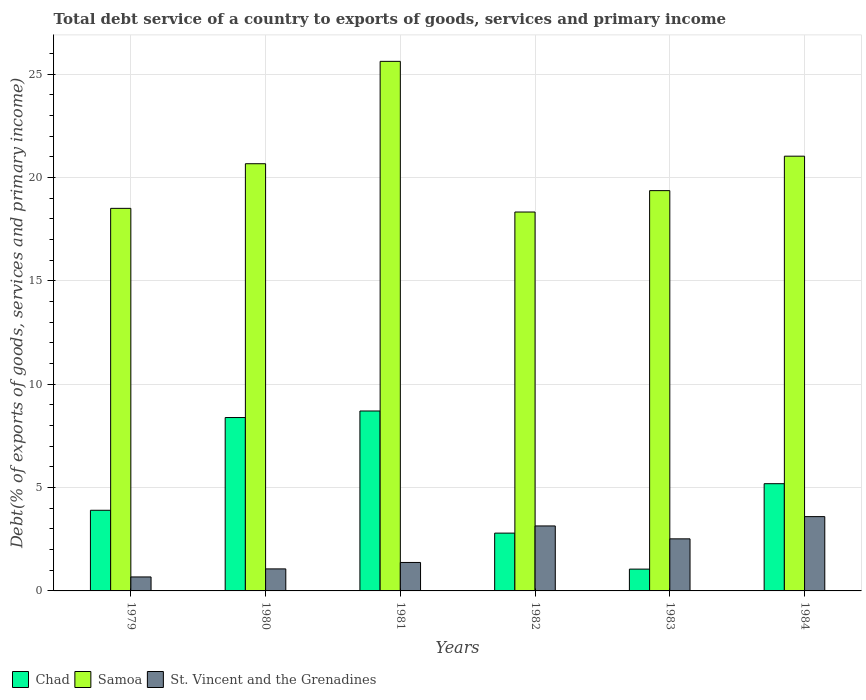Are the number of bars per tick equal to the number of legend labels?
Keep it short and to the point. Yes. How many bars are there on the 6th tick from the left?
Keep it short and to the point. 3. What is the total debt service in Samoa in 1981?
Your answer should be compact. 25.63. Across all years, what is the maximum total debt service in St. Vincent and the Grenadines?
Provide a succinct answer. 3.6. Across all years, what is the minimum total debt service in St. Vincent and the Grenadines?
Keep it short and to the point. 0.68. In which year was the total debt service in St. Vincent and the Grenadines minimum?
Offer a very short reply. 1979. What is the total total debt service in Samoa in the graph?
Ensure brevity in your answer.  123.55. What is the difference between the total debt service in St. Vincent and the Grenadines in 1980 and that in 1981?
Provide a short and direct response. -0.31. What is the difference between the total debt service in St. Vincent and the Grenadines in 1980 and the total debt service in Samoa in 1984?
Offer a very short reply. -19.97. What is the average total debt service in Chad per year?
Make the answer very short. 5.01. In the year 1984, what is the difference between the total debt service in Chad and total debt service in St. Vincent and the Grenadines?
Give a very brief answer. 1.59. In how many years, is the total debt service in Samoa greater than 2 %?
Your response must be concise. 6. What is the ratio of the total debt service in Samoa in 1981 to that in 1984?
Give a very brief answer. 1.22. What is the difference between the highest and the second highest total debt service in Chad?
Provide a succinct answer. 0.32. What is the difference between the highest and the lowest total debt service in Samoa?
Provide a short and direct response. 7.29. In how many years, is the total debt service in Samoa greater than the average total debt service in Samoa taken over all years?
Keep it short and to the point. 3. Is the sum of the total debt service in Chad in 1980 and 1982 greater than the maximum total debt service in Samoa across all years?
Provide a succinct answer. No. What does the 2nd bar from the left in 1983 represents?
Keep it short and to the point. Samoa. What does the 2nd bar from the right in 1984 represents?
Make the answer very short. Samoa. How many bars are there?
Your answer should be compact. 18. How many years are there in the graph?
Ensure brevity in your answer.  6. Does the graph contain any zero values?
Keep it short and to the point. No. Where does the legend appear in the graph?
Your answer should be very brief. Bottom left. What is the title of the graph?
Your answer should be very brief. Total debt service of a country to exports of goods, services and primary income. What is the label or title of the Y-axis?
Your answer should be very brief. Debt(% of exports of goods, services and primary income). What is the Debt(% of exports of goods, services and primary income) in Chad in 1979?
Your response must be concise. 3.9. What is the Debt(% of exports of goods, services and primary income) in Samoa in 1979?
Provide a short and direct response. 18.51. What is the Debt(% of exports of goods, services and primary income) in St. Vincent and the Grenadines in 1979?
Your answer should be compact. 0.68. What is the Debt(% of exports of goods, services and primary income) of Chad in 1980?
Your answer should be very brief. 8.39. What is the Debt(% of exports of goods, services and primary income) of Samoa in 1980?
Give a very brief answer. 20.67. What is the Debt(% of exports of goods, services and primary income) in St. Vincent and the Grenadines in 1980?
Provide a succinct answer. 1.07. What is the Debt(% of exports of goods, services and primary income) in Chad in 1981?
Ensure brevity in your answer.  8.71. What is the Debt(% of exports of goods, services and primary income) of Samoa in 1981?
Offer a very short reply. 25.63. What is the Debt(% of exports of goods, services and primary income) of St. Vincent and the Grenadines in 1981?
Ensure brevity in your answer.  1.38. What is the Debt(% of exports of goods, services and primary income) of Chad in 1982?
Keep it short and to the point. 2.8. What is the Debt(% of exports of goods, services and primary income) of Samoa in 1982?
Ensure brevity in your answer.  18.33. What is the Debt(% of exports of goods, services and primary income) of St. Vincent and the Grenadines in 1982?
Your response must be concise. 3.14. What is the Debt(% of exports of goods, services and primary income) in Chad in 1983?
Provide a short and direct response. 1.05. What is the Debt(% of exports of goods, services and primary income) of Samoa in 1983?
Ensure brevity in your answer.  19.37. What is the Debt(% of exports of goods, services and primary income) of St. Vincent and the Grenadines in 1983?
Offer a very short reply. 2.52. What is the Debt(% of exports of goods, services and primary income) of Chad in 1984?
Your response must be concise. 5.19. What is the Debt(% of exports of goods, services and primary income) in Samoa in 1984?
Your answer should be compact. 21.04. What is the Debt(% of exports of goods, services and primary income) in St. Vincent and the Grenadines in 1984?
Your answer should be compact. 3.6. Across all years, what is the maximum Debt(% of exports of goods, services and primary income) in Chad?
Your answer should be compact. 8.71. Across all years, what is the maximum Debt(% of exports of goods, services and primary income) in Samoa?
Provide a succinct answer. 25.63. Across all years, what is the maximum Debt(% of exports of goods, services and primary income) of St. Vincent and the Grenadines?
Keep it short and to the point. 3.6. Across all years, what is the minimum Debt(% of exports of goods, services and primary income) of Chad?
Your answer should be very brief. 1.05. Across all years, what is the minimum Debt(% of exports of goods, services and primary income) in Samoa?
Your response must be concise. 18.33. Across all years, what is the minimum Debt(% of exports of goods, services and primary income) in St. Vincent and the Grenadines?
Your answer should be compact. 0.68. What is the total Debt(% of exports of goods, services and primary income) in Chad in the graph?
Offer a very short reply. 30.04. What is the total Debt(% of exports of goods, services and primary income) of Samoa in the graph?
Give a very brief answer. 123.55. What is the total Debt(% of exports of goods, services and primary income) in St. Vincent and the Grenadines in the graph?
Offer a terse response. 12.38. What is the difference between the Debt(% of exports of goods, services and primary income) of Chad in 1979 and that in 1980?
Provide a short and direct response. -4.49. What is the difference between the Debt(% of exports of goods, services and primary income) in Samoa in 1979 and that in 1980?
Provide a short and direct response. -2.16. What is the difference between the Debt(% of exports of goods, services and primary income) of St. Vincent and the Grenadines in 1979 and that in 1980?
Your answer should be compact. -0.39. What is the difference between the Debt(% of exports of goods, services and primary income) of Chad in 1979 and that in 1981?
Give a very brief answer. -4.8. What is the difference between the Debt(% of exports of goods, services and primary income) of Samoa in 1979 and that in 1981?
Provide a succinct answer. -7.11. What is the difference between the Debt(% of exports of goods, services and primary income) in St. Vincent and the Grenadines in 1979 and that in 1981?
Provide a short and direct response. -0.7. What is the difference between the Debt(% of exports of goods, services and primary income) in Chad in 1979 and that in 1982?
Make the answer very short. 1.11. What is the difference between the Debt(% of exports of goods, services and primary income) in Samoa in 1979 and that in 1982?
Offer a terse response. 0.18. What is the difference between the Debt(% of exports of goods, services and primary income) of St. Vincent and the Grenadines in 1979 and that in 1982?
Ensure brevity in your answer.  -2.47. What is the difference between the Debt(% of exports of goods, services and primary income) in Chad in 1979 and that in 1983?
Provide a succinct answer. 2.85. What is the difference between the Debt(% of exports of goods, services and primary income) of Samoa in 1979 and that in 1983?
Keep it short and to the point. -0.86. What is the difference between the Debt(% of exports of goods, services and primary income) in St. Vincent and the Grenadines in 1979 and that in 1983?
Give a very brief answer. -1.84. What is the difference between the Debt(% of exports of goods, services and primary income) of Chad in 1979 and that in 1984?
Keep it short and to the point. -1.29. What is the difference between the Debt(% of exports of goods, services and primary income) in Samoa in 1979 and that in 1984?
Provide a short and direct response. -2.52. What is the difference between the Debt(% of exports of goods, services and primary income) of St. Vincent and the Grenadines in 1979 and that in 1984?
Keep it short and to the point. -2.92. What is the difference between the Debt(% of exports of goods, services and primary income) of Chad in 1980 and that in 1981?
Provide a succinct answer. -0.32. What is the difference between the Debt(% of exports of goods, services and primary income) of Samoa in 1980 and that in 1981?
Provide a succinct answer. -4.95. What is the difference between the Debt(% of exports of goods, services and primary income) in St. Vincent and the Grenadines in 1980 and that in 1981?
Your answer should be very brief. -0.31. What is the difference between the Debt(% of exports of goods, services and primary income) in Chad in 1980 and that in 1982?
Ensure brevity in your answer.  5.59. What is the difference between the Debt(% of exports of goods, services and primary income) of Samoa in 1980 and that in 1982?
Provide a short and direct response. 2.34. What is the difference between the Debt(% of exports of goods, services and primary income) of St. Vincent and the Grenadines in 1980 and that in 1982?
Your response must be concise. -2.08. What is the difference between the Debt(% of exports of goods, services and primary income) of Chad in 1980 and that in 1983?
Your response must be concise. 7.34. What is the difference between the Debt(% of exports of goods, services and primary income) in Samoa in 1980 and that in 1983?
Provide a succinct answer. 1.3. What is the difference between the Debt(% of exports of goods, services and primary income) of St. Vincent and the Grenadines in 1980 and that in 1983?
Your answer should be very brief. -1.45. What is the difference between the Debt(% of exports of goods, services and primary income) in Chad in 1980 and that in 1984?
Provide a succinct answer. 3.2. What is the difference between the Debt(% of exports of goods, services and primary income) of Samoa in 1980 and that in 1984?
Offer a terse response. -0.36. What is the difference between the Debt(% of exports of goods, services and primary income) in St. Vincent and the Grenadines in 1980 and that in 1984?
Your response must be concise. -2.53. What is the difference between the Debt(% of exports of goods, services and primary income) in Chad in 1981 and that in 1982?
Provide a short and direct response. 5.91. What is the difference between the Debt(% of exports of goods, services and primary income) of Samoa in 1981 and that in 1982?
Offer a very short reply. 7.29. What is the difference between the Debt(% of exports of goods, services and primary income) in St. Vincent and the Grenadines in 1981 and that in 1982?
Provide a short and direct response. -1.77. What is the difference between the Debt(% of exports of goods, services and primary income) in Chad in 1981 and that in 1983?
Your response must be concise. 7.65. What is the difference between the Debt(% of exports of goods, services and primary income) in Samoa in 1981 and that in 1983?
Provide a short and direct response. 6.26. What is the difference between the Debt(% of exports of goods, services and primary income) of St. Vincent and the Grenadines in 1981 and that in 1983?
Provide a succinct answer. -1.14. What is the difference between the Debt(% of exports of goods, services and primary income) of Chad in 1981 and that in 1984?
Give a very brief answer. 3.52. What is the difference between the Debt(% of exports of goods, services and primary income) in Samoa in 1981 and that in 1984?
Offer a terse response. 4.59. What is the difference between the Debt(% of exports of goods, services and primary income) in St. Vincent and the Grenadines in 1981 and that in 1984?
Ensure brevity in your answer.  -2.22. What is the difference between the Debt(% of exports of goods, services and primary income) in Chad in 1982 and that in 1983?
Make the answer very short. 1.74. What is the difference between the Debt(% of exports of goods, services and primary income) in Samoa in 1982 and that in 1983?
Offer a terse response. -1.04. What is the difference between the Debt(% of exports of goods, services and primary income) of St. Vincent and the Grenadines in 1982 and that in 1983?
Your answer should be compact. 0.62. What is the difference between the Debt(% of exports of goods, services and primary income) in Chad in 1982 and that in 1984?
Give a very brief answer. -2.39. What is the difference between the Debt(% of exports of goods, services and primary income) in Samoa in 1982 and that in 1984?
Ensure brevity in your answer.  -2.7. What is the difference between the Debt(% of exports of goods, services and primary income) of St. Vincent and the Grenadines in 1982 and that in 1984?
Ensure brevity in your answer.  -0.45. What is the difference between the Debt(% of exports of goods, services and primary income) of Chad in 1983 and that in 1984?
Offer a very short reply. -4.13. What is the difference between the Debt(% of exports of goods, services and primary income) of Samoa in 1983 and that in 1984?
Provide a succinct answer. -1.67. What is the difference between the Debt(% of exports of goods, services and primary income) of St. Vincent and the Grenadines in 1983 and that in 1984?
Provide a succinct answer. -1.08. What is the difference between the Debt(% of exports of goods, services and primary income) in Chad in 1979 and the Debt(% of exports of goods, services and primary income) in Samoa in 1980?
Offer a very short reply. -16.77. What is the difference between the Debt(% of exports of goods, services and primary income) in Chad in 1979 and the Debt(% of exports of goods, services and primary income) in St. Vincent and the Grenadines in 1980?
Provide a succinct answer. 2.84. What is the difference between the Debt(% of exports of goods, services and primary income) of Samoa in 1979 and the Debt(% of exports of goods, services and primary income) of St. Vincent and the Grenadines in 1980?
Offer a terse response. 17.45. What is the difference between the Debt(% of exports of goods, services and primary income) in Chad in 1979 and the Debt(% of exports of goods, services and primary income) in Samoa in 1981?
Your response must be concise. -21.72. What is the difference between the Debt(% of exports of goods, services and primary income) of Chad in 1979 and the Debt(% of exports of goods, services and primary income) of St. Vincent and the Grenadines in 1981?
Provide a succinct answer. 2.53. What is the difference between the Debt(% of exports of goods, services and primary income) of Samoa in 1979 and the Debt(% of exports of goods, services and primary income) of St. Vincent and the Grenadines in 1981?
Your answer should be compact. 17.14. What is the difference between the Debt(% of exports of goods, services and primary income) of Chad in 1979 and the Debt(% of exports of goods, services and primary income) of Samoa in 1982?
Ensure brevity in your answer.  -14.43. What is the difference between the Debt(% of exports of goods, services and primary income) in Chad in 1979 and the Debt(% of exports of goods, services and primary income) in St. Vincent and the Grenadines in 1982?
Provide a short and direct response. 0.76. What is the difference between the Debt(% of exports of goods, services and primary income) of Samoa in 1979 and the Debt(% of exports of goods, services and primary income) of St. Vincent and the Grenadines in 1982?
Your response must be concise. 15.37. What is the difference between the Debt(% of exports of goods, services and primary income) in Chad in 1979 and the Debt(% of exports of goods, services and primary income) in Samoa in 1983?
Your answer should be compact. -15.47. What is the difference between the Debt(% of exports of goods, services and primary income) in Chad in 1979 and the Debt(% of exports of goods, services and primary income) in St. Vincent and the Grenadines in 1983?
Give a very brief answer. 1.38. What is the difference between the Debt(% of exports of goods, services and primary income) in Samoa in 1979 and the Debt(% of exports of goods, services and primary income) in St. Vincent and the Grenadines in 1983?
Make the answer very short. 15.99. What is the difference between the Debt(% of exports of goods, services and primary income) in Chad in 1979 and the Debt(% of exports of goods, services and primary income) in Samoa in 1984?
Your answer should be very brief. -17.14. What is the difference between the Debt(% of exports of goods, services and primary income) of Chad in 1979 and the Debt(% of exports of goods, services and primary income) of St. Vincent and the Grenadines in 1984?
Your response must be concise. 0.31. What is the difference between the Debt(% of exports of goods, services and primary income) of Samoa in 1979 and the Debt(% of exports of goods, services and primary income) of St. Vincent and the Grenadines in 1984?
Provide a succinct answer. 14.92. What is the difference between the Debt(% of exports of goods, services and primary income) in Chad in 1980 and the Debt(% of exports of goods, services and primary income) in Samoa in 1981?
Give a very brief answer. -17.24. What is the difference between the Debt(% of exports of goods, services and primary income) in Chad in 1980 and the Debt(% of exports of goods, services and primary income) in St. Vincent and the Grenadines in 1981?
Offer a very short reply. 7.01. What is the difference between the Debt(% of exports of goods, services and primary income) of Samoa in 1980 and the Debt(% of exports of goods, services and primary income) of St. Vincent and the Grenadines in 1981?
Provide a short and direct response. 19.3. What is the difference between the Debt(% of exports of goods, services and primary income) in Chad in 1980 and the Debt(% of exports of goods, services and primary income) in Samoa in 1982?
Your answer should be compact. -9.94. What is the difference between the Debt(% of exports of goods, services and primary income) of Chad in 1980 and the Debt(% of exports of goods, services and primary income) of St. Vincent and the Grenadines in 1982?
Offer a terse response. 5.25. What is the difference between the Debt(% of exports of goods, services and primary income) of Samoa in 1980 and the Debt(% of exports of goods, services and primary income) of St. Vincent and the Grenadines in 1982?
Provide a succinct answer. 17.53. What is the difference between the Debt(% of exports of goods, services and primary income) in Chad in 1980 and the Debt(% of exports of goods, services and primary income) in Samoa in 1983?
Your answer should be very brief. -10.98. What is the difference between the Debt(% of exports of goods, services and primary income) in Chad in 1980 and the Debt(% of exports of goods, services and primary income) in St. Vincent and the Grenadines in 1983?
Give a very brief answer. 5.87. What is the difference between the Debt(% of exports of goods, services and primary income) in Samoa in 1980 and the Debt(% of exports of goods, services and primary income) in St. Vincent and the Grenadines in 1983?
Provide a short and direct response. 18.15. What is the difference between the Debt(% of exports of goods, services and primary income) in Chad in 1980 and the Debt(% of exports of goods, services and primary income) in Samoa in 1984?
Provide a short and direct response. -12.65. What is the difference between the Debt(% of exports of goods, services and primary income) in Chad in 1980 and the Debt(% of exports of goods, services and primary income) in St. Vincent and the Grenadines in 1984?
Give a very brief answer. 4.79. What is the difference between the Debt(% of exports of goods, services and primary income) in Samoa in 1980 and the Debt(% of exports of goods, services and primary income) in St. Vincent and the Grenadines in 1984?
Offer a very short reply. 17.08. What is the difference between the Debt(% of exports of goods, services and primary income) of Chad in 1981 and the Debt(% of exports of goods, services and primary income) of Samoa in 1982?
Provide a succinct answer. -9.63. What is the difference between the Debt(% of exports of goods, services and primary income) of Chad in 1981 and the Debt(% of exports of goods, services and primary income) of St. Vincent and the Grenadines in 1982?
Offer a terse response. 5.56. What is the difference between the Debt(% of exports of goods, services and primary income) in Samoa in 1981 and the Debt(% of exports of goods, services and primary income) in St. Vincent and the Grenadines in 1982?
Ensure brevity in your answer.  22.48. What is the difference between the Debt(% of exports of goods, services and primary income) in Chad in 1981 and the Debt(% of exports of goods, services and primary income) in Samoa in 1983?
Your response must be concise. -10.66. What is the difference between the Debt(% of exports of goods, services and primary income) in Chad in 1981 and the Debt(% of exports of goods, services and primary income) in St. Vincent and the Grenadines in 1983?
Offer a terse response. 6.19. What is the difference between the Debt(% of exports of goods, services and primary income) in Samoa in 1981 and the Debt(% of exports of goods, services and primary income) in St. Vincent and the Grenadines in 1983?
Ensure brevity in your answer.  23.11. What is the difference between the Debt(% of exports of goods, services and primary income) in Chad in 1981 and the Debt(% of exports of goods, services and primary income) in Samoa in 1984?
Offer a terse response. -12.33. What is the difference between the Debt(% of exports of goods, services and primary income) in Chad in 1981 and the Debt(% of exports of goods, services and primary income) in St. Vincent and the Grenadines in 1984?
Make the answer very short. 5.11. What is the difference between the Debt(% of exports of goods, services and primary income) in Samoa in 1981 and the Debt(% of exports of goods, services and primary income) in St. Vincent and the Grenadines in 1984?
Keep it short and to the point. 22.03. What is the difference between the Debt(% of exports of goods, services and primary income) of Chad in 1982 and the Debt(% of exports of goods, services and primary income) of Samoa in 1983?
Your answer should be compact. -16.57. What is the difference between the Debt(% of exports of goods, services and primary income) in Chad in 1982 and the Debt(% of exports of goods, services and primary income) in St. Vincent and the Grenadines in 1983?
Your answer should be compact. 0.28. What is the difference between the Debt(% of exports of goods, services and primary income) of Samoa in 1982 and the Debt(% of exports of goods, services and primary income) of St. Vincent and the Grenadines in 1983?
Offer a very short reply. 15.82. What is the difference between the Debt(% of exports of goods, services and primary income) in Chad in 1982 and the Debt(% of exports of goods, services and primary income) in Samoa in 1984?
Provide a short and direct response. -18.24. What is the difference between the Debt(% of exports of goods, services and primary income) in Chad in 1982 and the Debt(% of exports of goods, services and primary income) in St. Vincent and the Grenadines in 1984?
Provide a short and direct response. -0.8. What is the difference between the Debt(% of exports of goods, services and primary income) in Samoa in 1982 and the Debt(% of exports of goods, services and primary income) in St. Vincent and the Grenadines in 1984?
Your answer should be very brief. 14.74. What is the difference between the Debt(% of exports of goods, services and primary income) in Chad in 1983 and the Debt(% of exports of goods, services and primary income) in Samoa in 1984?
Provide a succinct answer. -19.98. What is the difference between the Debt(% of exports of goods, services and primary income) in Chad in 1983 and the Debt(% of exports of goods, services and primary income) in St. Vincent and the Grenadines in 1984?
Provide a succinct answer. -2.54. What is the difference between the Debt(% of exports of goods, services and primary income) in Samoa in 1983 and the Debt(% of exports of goods, services and primary income) in St. Vincent and the Grenadines in 1984?
Make the answer very short. 15.78. What is the average Debt(% of exports of goods, services and primary income) of Chad per year?
Your response must be concise. 5.01. What is the average Debt(% of exports of goods, services and primary income) in Samoa per year?
Your answer should be very brief. 20.59. What is the average Debt(% of exports of goods, services and primary income) of St. Vincent and the Grenadines per year?
Offer a very short reply. 2.06. In the year 1979, what is the difference between the Debt(% of exports of goods, services and primary income) of Chad and Debt(% of exports of goods, services and primary income) of Samoa?
Your response must be concise. -14.61. In the year 1979, what is the difference between the Debt(% of exports of goods, services and primary income) of Chad and Debt(% of exports of goods, services and primary income) of St. Vincent and the Grenadines?
Provide a short and direct response. 3.23. In the year 1979, what is the difference between the Debt(% of exports of goods, services and primary income) in Samoa and Debt(% of exports of goods, services and primary income) in St. Vincent and the Grenadines?
Provide a succinct answer. 17.84. In the year 1980, what is the difference between the Debt(% of exports of goods, services and primary income) in Chad and Debt(% of exports of goods, services and primary income) in Samoa?
Your answer should be very brief. -12.28. In the year 1980, what is the difference between the Debt(% of exports of goods, services and primary income) of Chad and Debt(% of exports of goods, services and primary income) of St. Vincent and the Grenadines?
Offer a terse response. 7.32. In the year 1980, what is the difference between the Debt(% of exports of goods, services and primary income) in Samoa and Debt(% of exports of goods, services and primary income) in St. Vincent and the Grenadines?
Make the answer very short. 19.61. In the year 1981, what is the difference between the Debt(% of exports of goods, services and primary income) of Chad and Debt(% of exports of goods, services and primary income) of Samoa?
Your answer should be very brief. -16.92. In the year 1981, what is the difference between the Debt(% of exports of goods, services and primary income) of Chad and Debt(% of exports of goods, services and primary income) of St. Vincent and the Grenadines?
Give a very brief answer. 7.33. In the year 1981, what is the difference between the Debt(% of exports of goods, services and primary income) of Samoa and Debt(% of exports of goods, services and primary income) of St. Vincent and the Grenadines?
Keep it short and to the point. 24.25. In the year 1982, what is the difference between the Debt(% of exports of goods, services and primary income) in Chad and Debt(% of exports of goods, services and primary income) in Samoa?
Make the answer very short. -15.54. In the year 1982, what is the difference between the Debt(% of exports of goods, services and primary income) in Chad and Debt(% of exports of goods, services and primary income) in St. Vincent and the Grenadines?
Your answer should be very brief. -0.35. In the year 1982, what is the difference between the Debt(% of exports of goods, services and primary income) of Samoa and Debt(% of exports of goods, services and primary income) of St. Vincent and the Grenadines?
Give a very brief answer. 15.19. In the year 1983, what is the difference between the Debt(% of exports of goods, services and primary income) of Chad and Debt(% of exports of goods, services and primary income) of Samoa?
Keep it short and to the point. -18.32. In the year 1983, what is the difference between the Debt(% of exports of goods, services and primary income) in Chad and Debt(% of exports of goods, services and primary income) in St. Vincent and the Grenadines?
Your response must be concise. -1.46. In the year 1983, what is the difference between the Debt(% of exports of goods, services and primary income) in Samoa and Debt(% of exports of goods, services and primary income) in St. Vincent and the Grenadines?
Your response must be concise. 16.85. In the year 1984, what is the difference between the Debt(% of exports of goods, services and primary income) of Chad and Debt(% of exports of goods, services and primary income) of Samoa?
Offer a terse response. -15.85. In the year 1984, what is the difference between the Debt(% of exports of goods, services and primary income) in Chad and Debt(% of exports of goods, services and primary income) in St. Vincent and the Grenadines?
Offer a terse response. 1.59. In the year 1984, what is the difference between the Debt(% of exports of goods, services and primary income) in Samoa and Debt(% of exports of goods, services and primary income) in St. Vincent and the Grenadines?
Offer a very short reply. 17.44. What is the ratio of the Debt(% of exports of goods, services and primary income) of Chad in 1979 to that in 1980?
Provide a succinct answer. 0.47. What is the ratio of the Debt(% of exports of goods, services and primary income) of Samoa in 1979 to that in 1980?
Ensure brevity in your answer.  0.9. What is the ratio of the Debt(% of exports of goods, services and primary income) in St. Vincent and the Grenadines in 1979 to that in 1980?
Offer a terse response. 0.64. What is the ratio of the Debt(% of exports of goods, services and primary income) of Chad in 1979 to that in 1981?
Make the answer very short. 0.45. What is the ratio of the Debt(% of exports of goods, services and primary income) of Samoa in 1979 to that in 1981?
Your answer should be very brief. 0.72. What is the ratio of the Debt(% of exports of goods, services and primary income) of St. Vincent and the Grenadines in 1979 to that in 1981?
Give a very brief answer. 0.49. What is the ratio of the Debt(% of exports of goods, services and primary income) in Chad in 1979 to that in 1982?
Provide a short and direct response. 1.4. What is the ratio of the Debt(% of exports of goods, services and primary income) in Samoa in 1979 to that in 1982?
Give a very brief answer. 1.01. What is the ratio of the Debt(% of exports of goods, services and primary income) of St. Vincent and the Grenadines in 1979 to that in 1982?
Your answer should be compact. 0.22. What is the ratio of the Debt(% of exports of goods, services and primary income) in Chad in 1979 to that in 1983?
Make the answer very short. 3.7. What is the ratio of the Debt(% of exports of goods, services and primary income) in Samoa in 1979 to that in 1983?
Provide a short and direct response. 0.96. What is the ratio of the Debt(% of exports of goods, services and primary income) of St. Vincent and the Grenadines in 1979 to that in 1983?
Provide a succinct answer. 0.27. What is the ratio of the Debt(% of exports of goods, services and primary income) of Chad in 1979 to that in 1984?
Make the answer very short. 0.75. What is the ratio of the Debt(% of exports of goods, services and primary income) of Samoa in 1979 to that in 1984?
Offer a terse response. 0.88. What is the ratio of the Debt(% of exports of goods, services and primary income) of St. Vincent and the Grenadines in 1979 to that in 1984?
Your answer should be very brief. 0.19. What is the ratio of the Debt(% of exports of goods, services and primary income) in Chad in 1980 to that in 1981?
Your response must be concise. 0.96. What is the ratio of the Debt(% of exports of goods, services and primary income) in Samoa in 1980 to that in 1981?
Keep it short and to the point. 0.81. What is the ratio of the Debt(% of exports of goods, services and primary income) in St. Vincent and the Grenadines in 1980 to that in 1981?
Keep it short and to the point. 0.77. What is the ratio of the Debt(% of exports of goods, services and primary income) in Chad in 1980 to that in 1982?
Your answer should be very brief. 3. What is the ratio of the Debt(% of exports of goods, services and primary income) of Samoa in 1980 to that in 1982?
Your answer should be compact. 1.13. What is the ratio of the Debt(% of exports of goods, services and primary income) in St. Vincent and the Grenadines in 1980 to that in 1982?
Your answer should be compact. 0.34. What is the ratio of the Debt(% of exports of goods, services and primary income) of Chad in 1980 to that in 1983?
Your response must be concise. 7.95. What is the ratio of the Debt(% of exports of goods, services and primary income) of Samoa in 1980 to that in 1983?
Your answer should be very brief. 1.07. What is the ratio of the Debt(% of exports of goods, services and primary income) in St. Vincent and the Grenadines in 1980 to that in 1983?
Your answer should be very brief. 0.42. What is the ratio of the Debt(% of exports of goods, services and primary income) of Chad in 1980 to that in 1984?
Provide a succinct answer. 1.62. What is the ratio of the Debt(% of exports of goods, services and primary income) in Samoa in 1980 to that in 1984?
Your response must be concise. 0.98. What is the ratio of the Debt(% of exports of goods, services and primary income) of St. Vincent and the Grenadines in 1980 to that in 1984?
Your answer should be very brief. 0.3. What is the ratio of the Debt(% of exports of goods, services and primary income) of Chad in 1981 to that in 1982?
Your answer should be very brief. 3.11. What is the ratio of the Debt(% of exports of goods, services and primary income) in Samoa in 1981 to that in 1982?
Your answer should be compact. 1.4. What is the ratio of the Debt(% of exports of goods, services and primary income) of St. Vincent and the Grenadines in 1981 to that in 1982?
Offer a terse response. 0.44. What is the ratio of the Debt(% of exports of goods, services and primary income) in Chad in 1981 to that in 1983?
Your answer should be compact. 8.25. What is the ratio of the Debt(% of exports of goods, services and primary income) in Samoa in 1981 to that in 1983?
Your answer should be very brief. 1.32. What is the ratio of the Debt(% of exports of goods, services and primary income) in St. Vincent and the Grenadines in 1981 to that in 1983?
Give a very brief answer. 0.55. What is the ratio of the Debt(% of exports of goods, services and primary income) of Chad in 1981 to that in 1984?
Provide a short and direct response. 1.68. What is the ratio of the Debt(% of exports of goods, services and primary income) in Samoa in 1981 to that in 1984?
Keep it short and to the point. 1.22. What is the ratio of the Debt(% of exports of goods, services and primary income) of St. Vincent and the Grenadines in 1981 to that in 1984?
Your answer should be very brief. 0.38. What is the ratio of the Debt(% of exports of goods, services and primary income) of Chad in 1982 to that in 1983?
Ensure brevity in your answer.  2.65. What is the ratio of the Debt(% of exports of goods, services and primary income) of Samoa in 1982 to that in 1983?
Your response must be concise. 0.95. What is the ratio of the Debt(% of exports of goods, services and primary income) in St. Vincent and the Grenadines in 1982 to that in 1983?
Your answer should be compact. 1.25. What is the ratio of the Debt(% of exports of goods, services and primary income) of Chad in 1982 to that in 1984?
Offer a terse response. 0.54. What is the ratio of the Debt(% of exports of goods, services and primary income) in Samoa in 1982 to that in 1984?
Ensure brevity in your answer.  0.87. What is the ratio of the Debt(% of exports of goods, services and primary income) of St. Vincent and the Grenadines in 1982 to that in 1984?
Provide a short and direct response. 0.87. What is the ratio of the Debt(% of exports of goods, services and primary income) of Chad in 1983 to that in 1984?
Provide a short and direct response. 0.2. What is the ratio of the Debt(% of exports of goods, services and primary income) of Samoa in 1983 to that in 1984?
Provide a short and direct response. 0.92. What is the ratio of the Debt(% of exports of goods, services and primary income) in St. Vincent and the Grenadines in 1983 to that in 1984?
Offer a terse response. 0.7. What is the difference between the highest and the second highest Debt(% of exports of goods, services and primary income) in Chad?
Offer a terse response. 0.32. What is the difference between the highest and the second highest Debt(% of exports of goods, services and primary income) of Samoa?
Your answer should be compact. 4.59. What is the difference between the highest and the second highest Debt(% of exports of goods, services and primary income) of St. Vincent and the Grenadines?
Provide a short and direct response. 0.45. What is the difference between the highest and the lowest Debt(% of exports of goods, services and primary income) of Chad?
Provide a succinct answer. 7.65. What is the difference between the highest and the lowest Debt(% of exports of goods, services and primary income) in Samoa?
Provide a succinct answer. 7.29. What is the difference between the highest and the lowest Debt(% of exports of goods, services and primary income) of St. Vincent and the Grenadines?
Your answer should be compact. 2.92. 